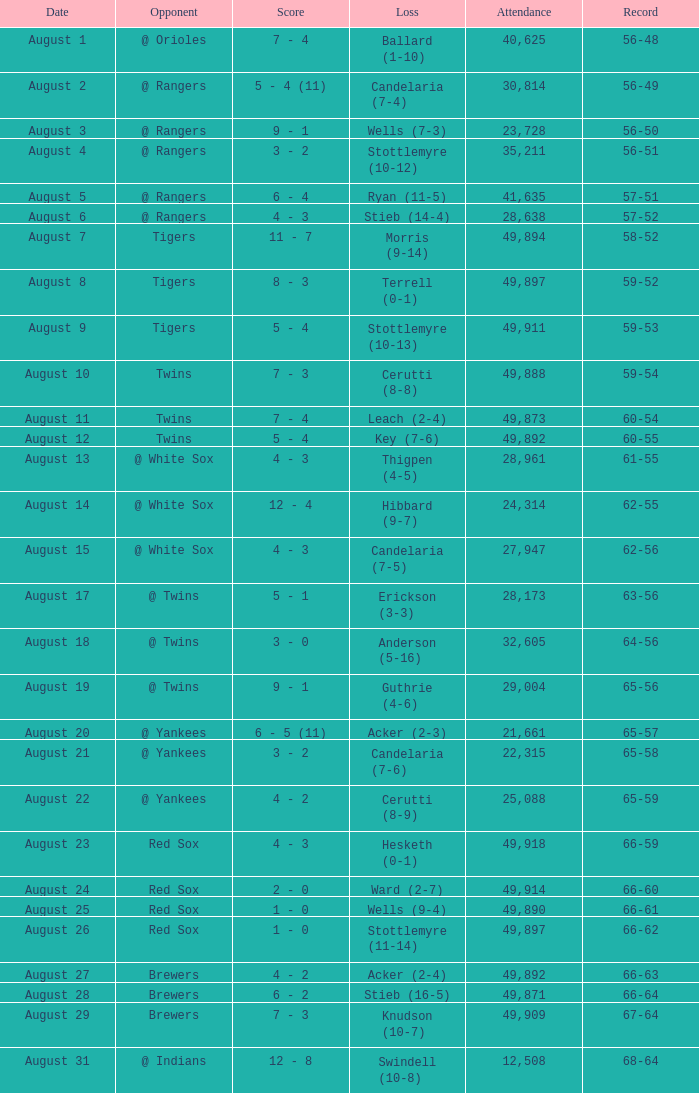What was the record of the game that had a loss of Stottlemyre (10-12)? 56-51. 